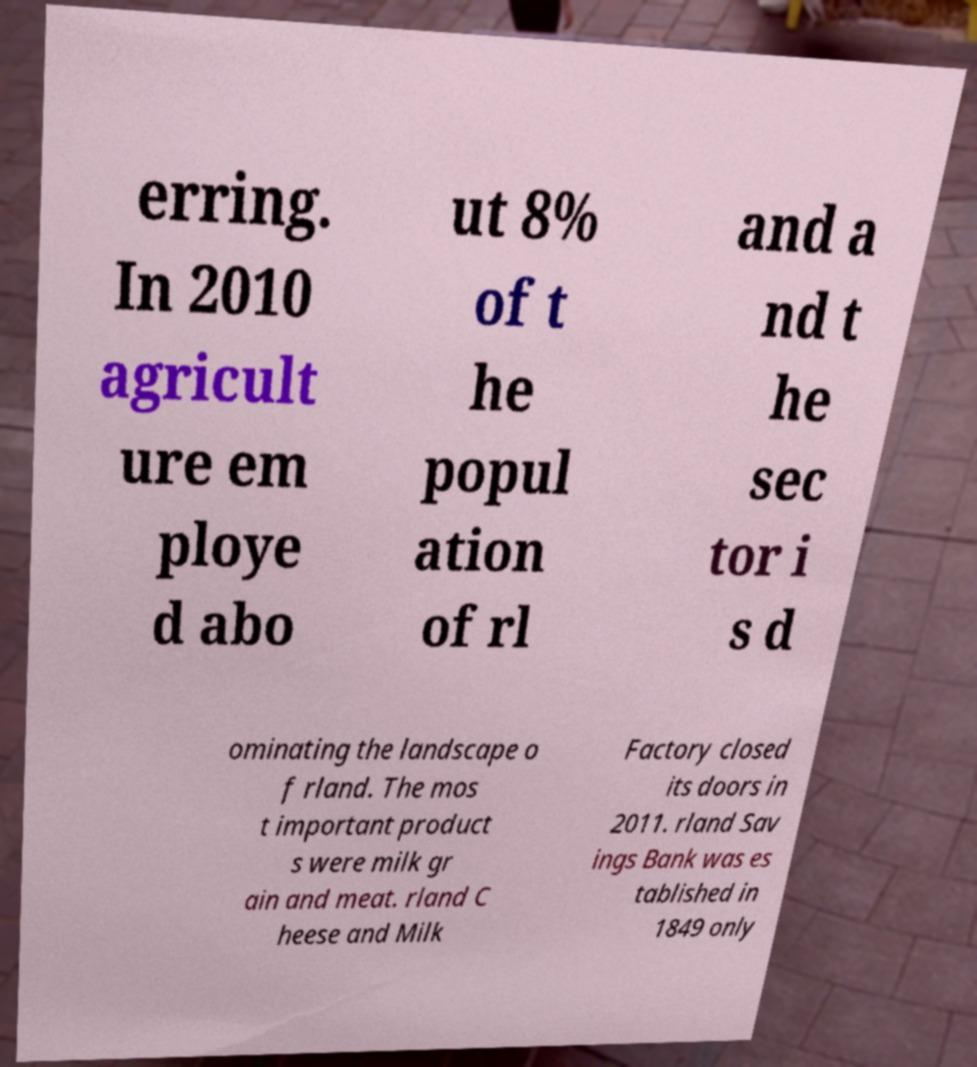There's text embedded in this image that I need extracted. Can you transcribe it verbatim? erring. In 2010 agricult ure em ploye d abo ut 8% of t he popul ation of rl and a nd t he sec tor i s d ominating the landscape o f rland. The mos t important product s were milk gr ain and meat. rland C heese and Milk Factory closed its doors in 2011. rland Sav ings Bank was es tablished in 1849 only 